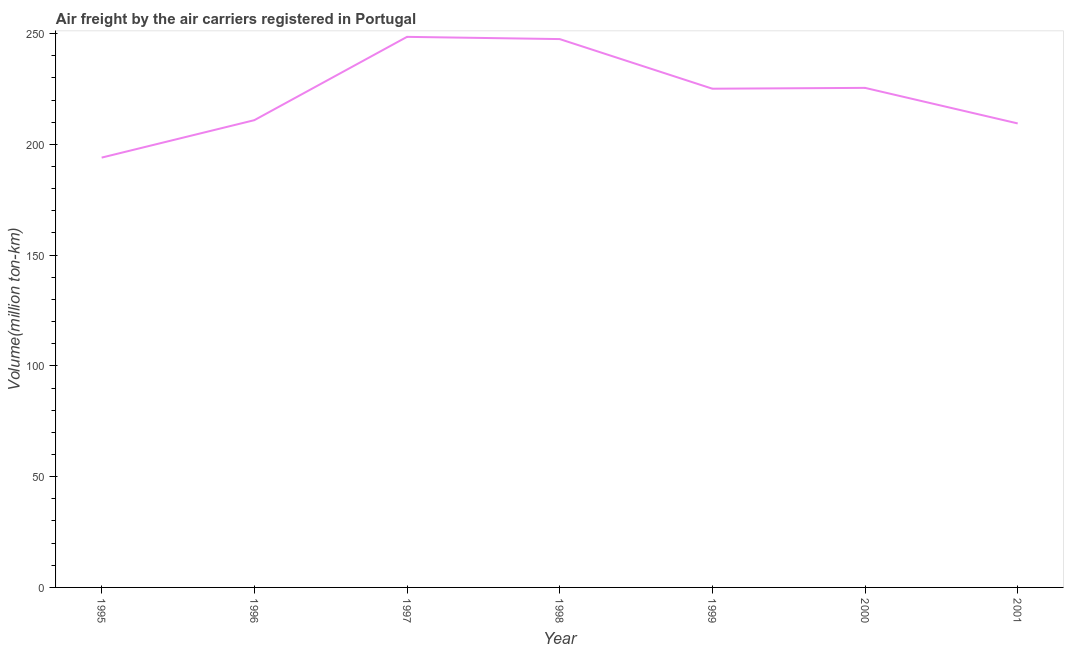What is the air freight in 1995?
Give a very brief answer. 194. Across all years, what is the maximum air freight?
Offer a very short reply. 248.5. Across all years, what is the minimum air freight?
Offer a terse response. 194. In which year was the air freight minimum?
Offer a terse response. 1995. What is the sum of the air freight?
Provide a short and direct response. 1560.9. What is the difference between the air freight in 1996 and 2001?
Your answer should be very brief. 1.47. What is the average air freight per year?
Make the answer very short. 222.99. What is the median air freight?
Provide a succinct answer. 225.1. What is the ratio of the air freight in 1998 to that in 2001?
Your answer should be very brief. 1.18. Is the air freight in 1999 less than that in 2001?
Offer a terse response. No. What is the difference between the highest and the lowest air freight?
Offer a very short reply. 54.5. How many lines are there?
Make the answer very short. 1. How many years are there in the graph?
Your answer should be compact. 7. Are the values on the major ticks of Y-axis written in scientific E-notation?
Keep it short and to the point. No. What is the title of the graph?
Offer a very short reply. Air freight by the air carriers registered in Portugal. What is the label or title of the Y-axis?
Keep it short and to the point. Volume(million ton-km). What is the Volume(million ton-km) of 1995?
Keep it short and to the point. 194. What is the Volume(million ton-km) in 1996?
Your answer should be very brief. 210.9. What is the Volume(million ton-km) in 1997?
Provide a succinct answer. 248.5. What is the Volume(million ton-km) in 1998?
Your response must be concise. 247.5. What is the Volume(million ton-km) of 1999?
Ensure brevity in your answer.  225.1. What is the Volume(million ton-km) of 2000?
Make the answer very short. 225.47. What is the Volume(million ton-km) in 2001?
Ensure brevity in your answer.  209.43. What is the difference between the Volume(million ton-km) in 1995 and 1996?
Ensure brevity in your answer.  -16.9. What is the difference between the Volume(million ton-km) in 1995 and 1997?
Provide a succinct answer. -54.5. What is the difference between the Volume(million ton-km) in 1995 and 1998?
Your answer should be compact. -53.5. What is the difference between the Volume(million ton-km) in 1995 and 1999?
Your response must be concise. -31.1. What is the difference between the Volume(million ton-km) in 1995 and 2000?
Offer a terse response. -31.48. What is the difference between the Volume(million ton-km) in 1995 and 2001?
Offer a very short reply. -15.43. What is the difference between the Volume(million ton-km) in 1996 and 1997?
Make the answer very short. -37.6. What is the difference between the Volume(million ton-km) in 1996 and 1998?
Give a very brief answer. -36.6. What is the difference between the Volume(million ton-km) in 1996 and 1999?
Provide a short and direct response. -14.2. What is the difference between the Volume(million ton-km) in 1996 and 2000?
Your response must be concise. -14.58. What is the difference between the Volume(million ton-km) in 1996 and 2001?
Offer a terse response. 1.47. What is the difference between the Volume(million ton-km) in 1997 and 1998?
Give a very brief answer. 1. What is the difference between the Volume(million ton-km) in 1997 and 1999?
Your answer should be very brief. 23.4. What is the difference between the Volume(million ton-km) in 1997 and 2000?
Provide a succinct answer. 23.02. What is the difference between the Volume(million ton-km) in 1997 and 2001?
Your answer should be very brief. 39.07. What is the difference between the Volume(million ton-km) in 1998 and 1999?
Give a very brief answer. 22.4. What is the difference between the Volume(million ton-km) in 1998 and 2000?
Offer a very short reply. 22.02. What is the difference between the Volume(million ton-km) in 1998 and 2001?
Provide a short and direct response. 38.07. What is the difference between the Volume(million ton-km) in 1999 and 2000?
Ensure brevity in your answer.  -0.37. What is the difference between the Volume(million ton-km) in 1999 and 2001?
Offer a very short reply. 15.67. What is the difference between the Volume(million ton-km) in 2000 and 2001?
Make the answer very short. 16.05. What is the ratio of the Volume(million ton-km) in 1995 to that in 1997?
Offer a terse response. 0.78. What is the ratio of the Volume(million ton-km) in 1995 to that in 1998?
Offer a terse response. 0.78. What is the ratio of the Volume(million ton-km) in 1995 to that in 1999?
Your answer should be compact. 0.86. What is the ratio of the Volume(million ton-km) in 1995 to that in 2000?
Keep it short and to the point. 0.86. What is the ratio of the Volume(million ton-km) in 1995 to that in 2001?
Make the answer very short. 0.93. What is the ratio of the Volume(million ton-km) in 1996 to that in 1997?
Keep it short and to the point. 0.85. What is the ratio of the Volume(million ton-km) in 1996 to that in 1998?
Your answer should be compact. 0.85. What is the ratio of the Volume(million ton-km) in 1996 to that in 1999?
Keep it short and to the point. 0.94. What is the ratio of the Volume(million ton-km) in 1996 to that in 2000?
Your response must be concise. 0.94. What is the ratio of the Volume(million ton-km) in 1996 to that in 2001?
Ensure brevity in your answer.  1.01. What is the ratio of the Volume(million ton-km) in 1997 to that in 1999?
Your response must be concise. 1.1. What is the ratio of the Volume(million ton-km) in 1997 to that in 2000?
Your answer should be very brief. 1.1. What is the ratio of the Volume(million ton-km) in 1997 to that in 2001?
Your response must be concise. 1.19. What is the ratio of the Volume(million ton-km) in 1998 to that in 2000?
Make the answer very short. 1.1. What is the ratio of the Volume(million ton-km) in 1998 to that in 2001?
Keep it short and to the point. 1.18. What is the ratio of the Volume(million ton-km) in 1999 to that in 2001?
Your response must be concise. 1.07. What is the ratio of the Volume(million ton-km) in 2000 to that in 2001?
Give a very brief answer. 1.08. 